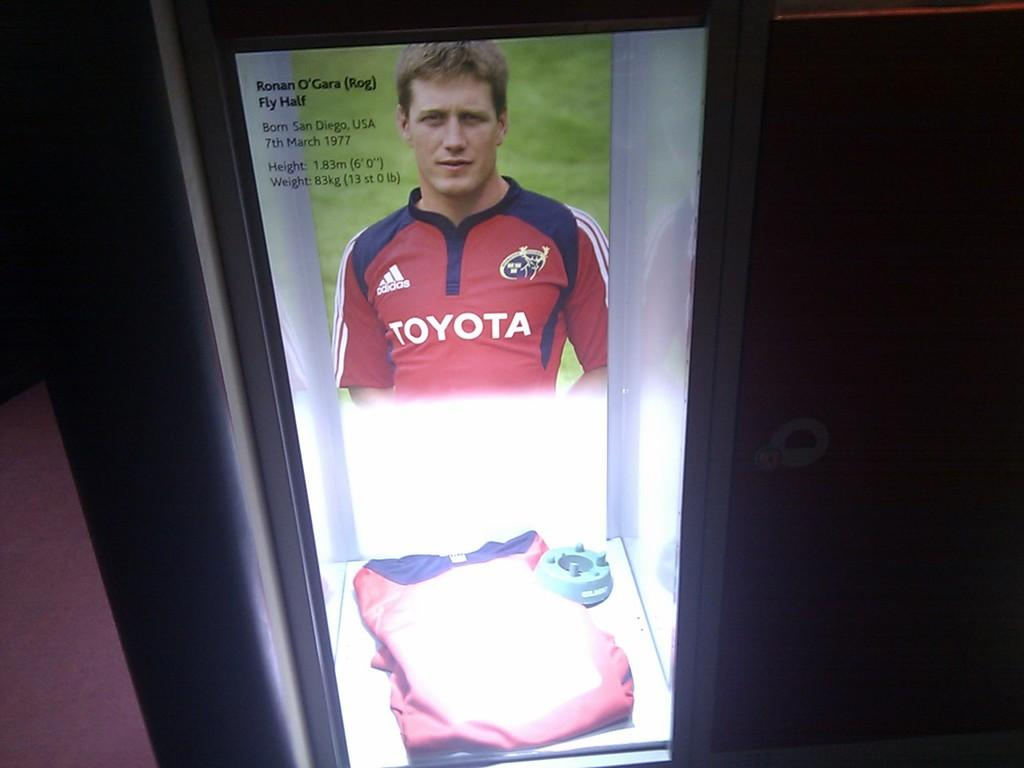<image>
Share a concise interpretation of the image provided. Athlete that has a maroon shirt on with Toyota in white across the front. 